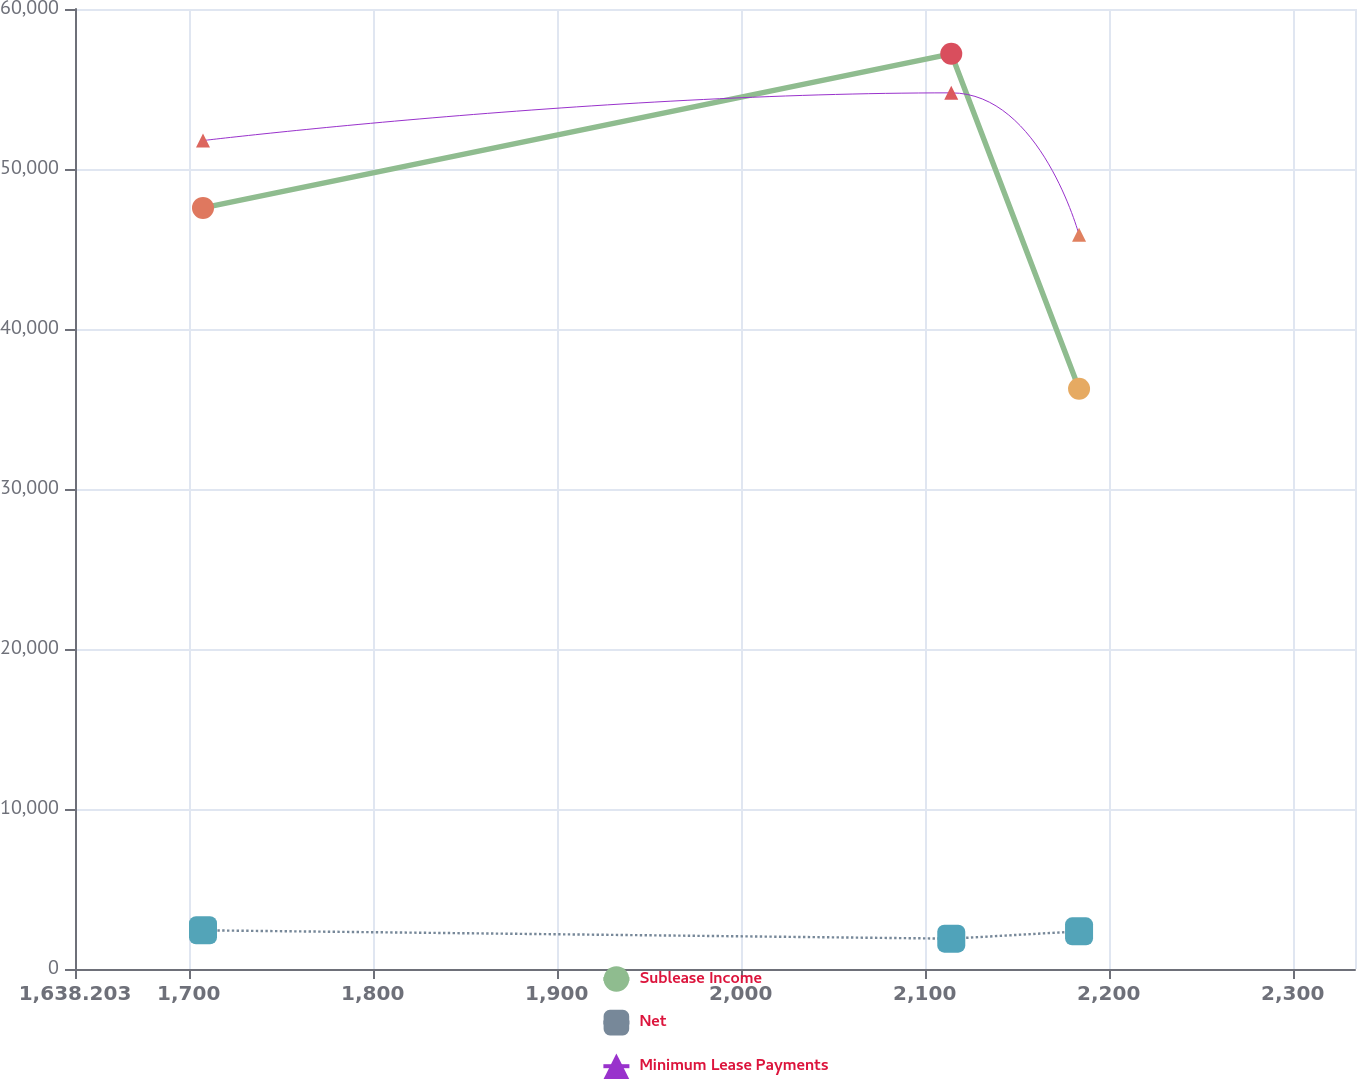<chart> <loc_0><loc_0><loc_500><loc_500><line_chart><ecel><fcel>Sublease Income<fcel>Net<fcel>Minimum Lease Payments<nl><fcel>1707.77<fcel>47569.4<fcel>2418.11<fcel>51778.2<nl><fcel>2114.45<fcel>57199.9<fcel>1895.82<fcel>54759.2<nl><fcel>2183.9<fcel>36267.7<fcel>2353.09<fcel>45887.3<nl><fcel>2333.99<fcel>32976.6<fcel>2288.33<fcel>35301.3<nl><fcel>2403.44<fcel>24288.1<fcel>2543.47<fcel>22957.6<nl></chart> 